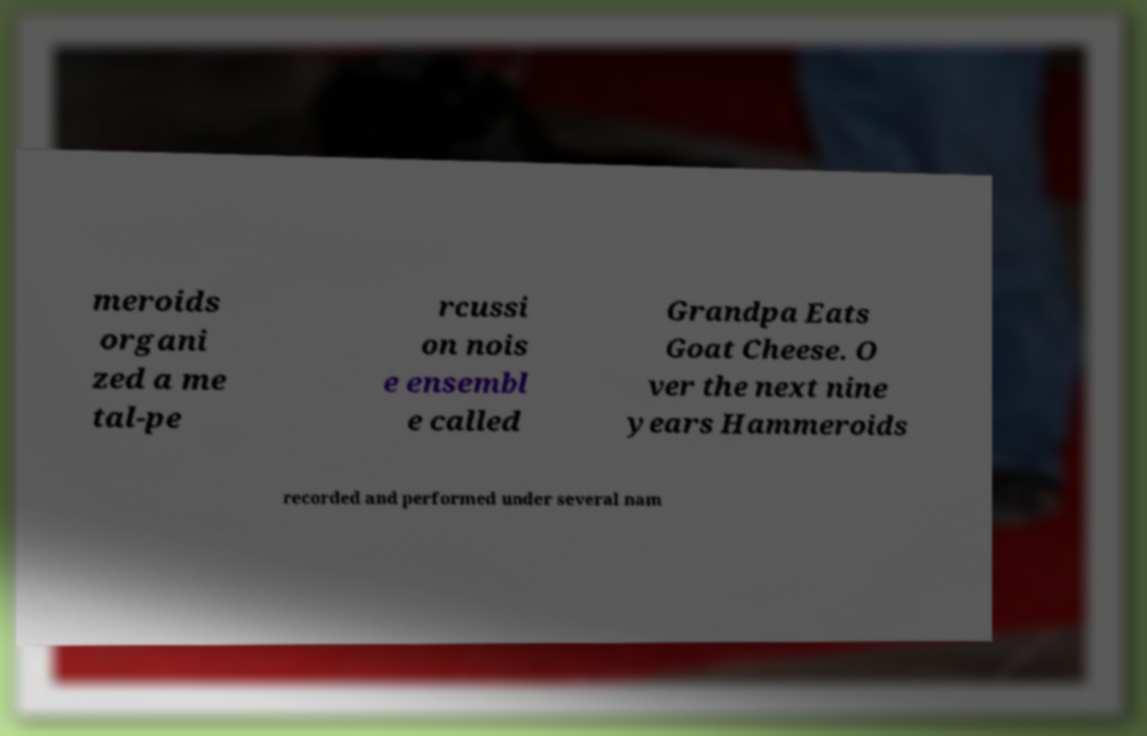What messages or text are displayed in this image? I need them in a readable, typed format. meroids organi zed a me tal-pe rcussi on nois e ensembl e called Grandpa Eats Goat Cheese. O ver the next nine years Hammeroids recorded and performed under several nam 